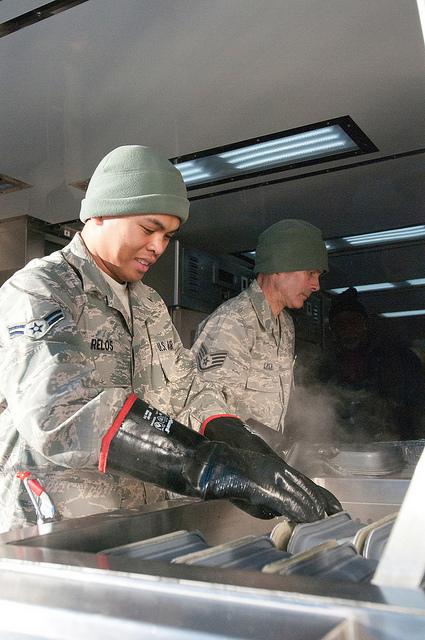What color shirt is the black gentleman wearing?
Short answer required. Camouflage. Are the gloves he is wearing kitchen gloves?
Quick response, please. No. In what branch of the service do these men serve?
Give a very brief answer. Army. 